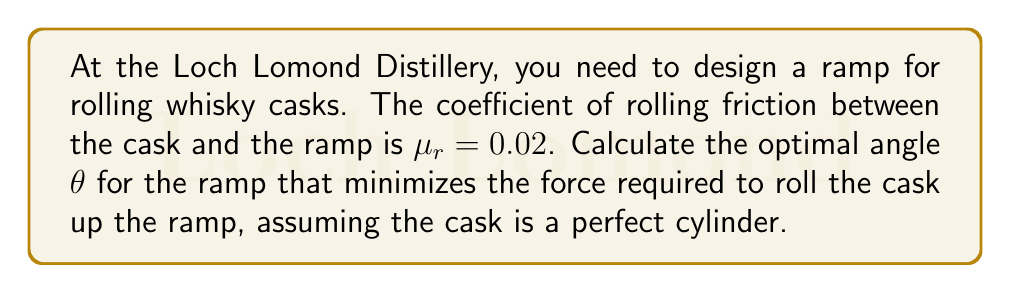Solve this math problem. To find the optimal angle, we need to minimize the total force required to roll the cask up the ramp. Let's approach this step-by-step:

1) The force required to roll the cask up the ramp is composed of two components:
   a) The force to overcome gravity (parallel to the ramp)
   b) The force to overcome rolling resistance

2) The force parallel to the ramp due to gravity is:
   $$F_g = mg\sin\theta$$
   where $m$ is the mass of the cask, $g$ is the acceleration due to gravity, and $\theta$ is the angle of the ramp.

3) The normal force on the ramp is:
   $$N = mg\cos\theta$$

4) The rolling resistance force is:
   $$F_r = \mu_r N = \mu_r mg\cos\theta$$

5) The total force required is the sum of these forces:
   $$F_{total} = F_g + F_r = mg\sin\theta + \mu_r mg\cos\theta$$

6) To find the minimum force, we differentiate $F_{total}$ with respect to $\theta$ and set it to zero:
   $$\frac{dF_{total}}{d\theta} = mg\cos\theta - \mu_r mg\sin\theta = 0$$

7) Solving this equation:
   $$\cos\theta = \mu_r \sin\theta$$
   $$\tan\theta = \frac{1}{\mu_r}$$

8) Therefore, the optimal angle is:
   $$\theta = \arctan(\frac{1}{\mu_r})$$

9) Substituting the given value of $\mu_r = 0.02$:
   $$\theta = \arctan(\frac{1}{0.02}) \approx 88.85°$$
Answer: $88.85°$ 